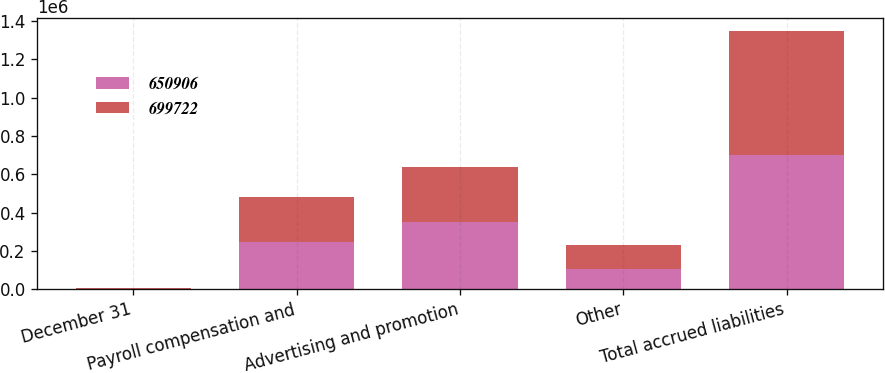Convert chart to OTSL. <chart><loc_0><loc_0><loc_500><loc_500><stacked_bar_chart><ecel><fcel>December 31<fcel>Payroll compensation and<fcel>Advertising and promotion<fcel>Other<fcel>Total accrued liabilities<nl><fcel>650906<fcel>2013<fcel>245641<fcel>348966<fcel>105115<fcel>699722<nl><fcel>699722<fcel>2012<fcel>236598<fcel>289221<fcel>125087<fcel>650906<nl></chart> 